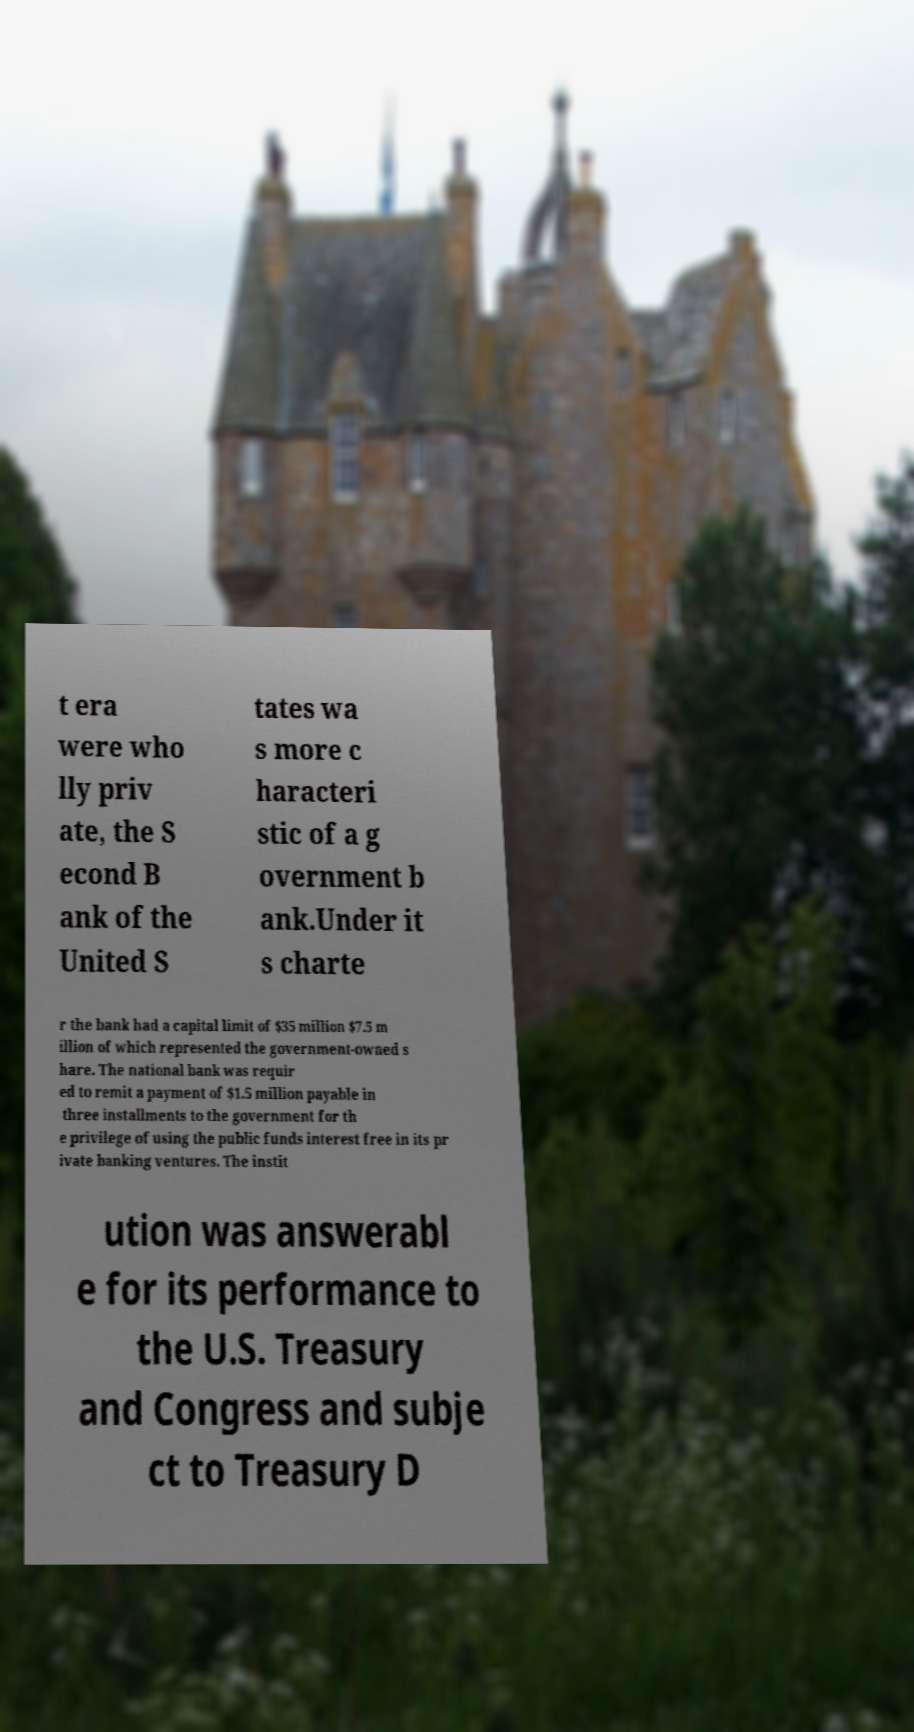What messages or text are displayed in this image? I need them in a readable, typed format. t era were who lly priv ate, the S econd B ank of the United S tates wa s more c haracteri stic of a g overnment b ank.Under it s charte r the bank had a capital limit of $35 million $7.5 m illion of which represented the government-owned s hare. The national bank was requir ed to remit a payment of $1.5 million payable in three installments to the government for th e privilege of using the public funds interest free in its pr ivate banking ventures. The instit ution was answerabl e for its performance to the U.S. Treasury and Congress and subje ct to Treasury D 